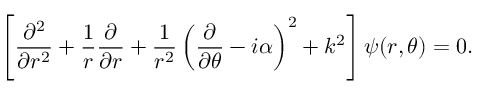<formula> <loc_0><loc_0><loc_500><loc_500>\left [ { \frac { \partial ^ { 2 } } { \partial r ^ { 2 } } } + { \frac { 1 } { r } } { \frac { \partial } { \partial r } } + { \frac { 1 } { r ^ { 2 } } } \left ( { \frac { \partial } { \partial \theta } } - i \alpha \right ) ^ { 2 } + k ^ { 2 } \right ] \psi ( r , \theta ) = 0 .</formula> 